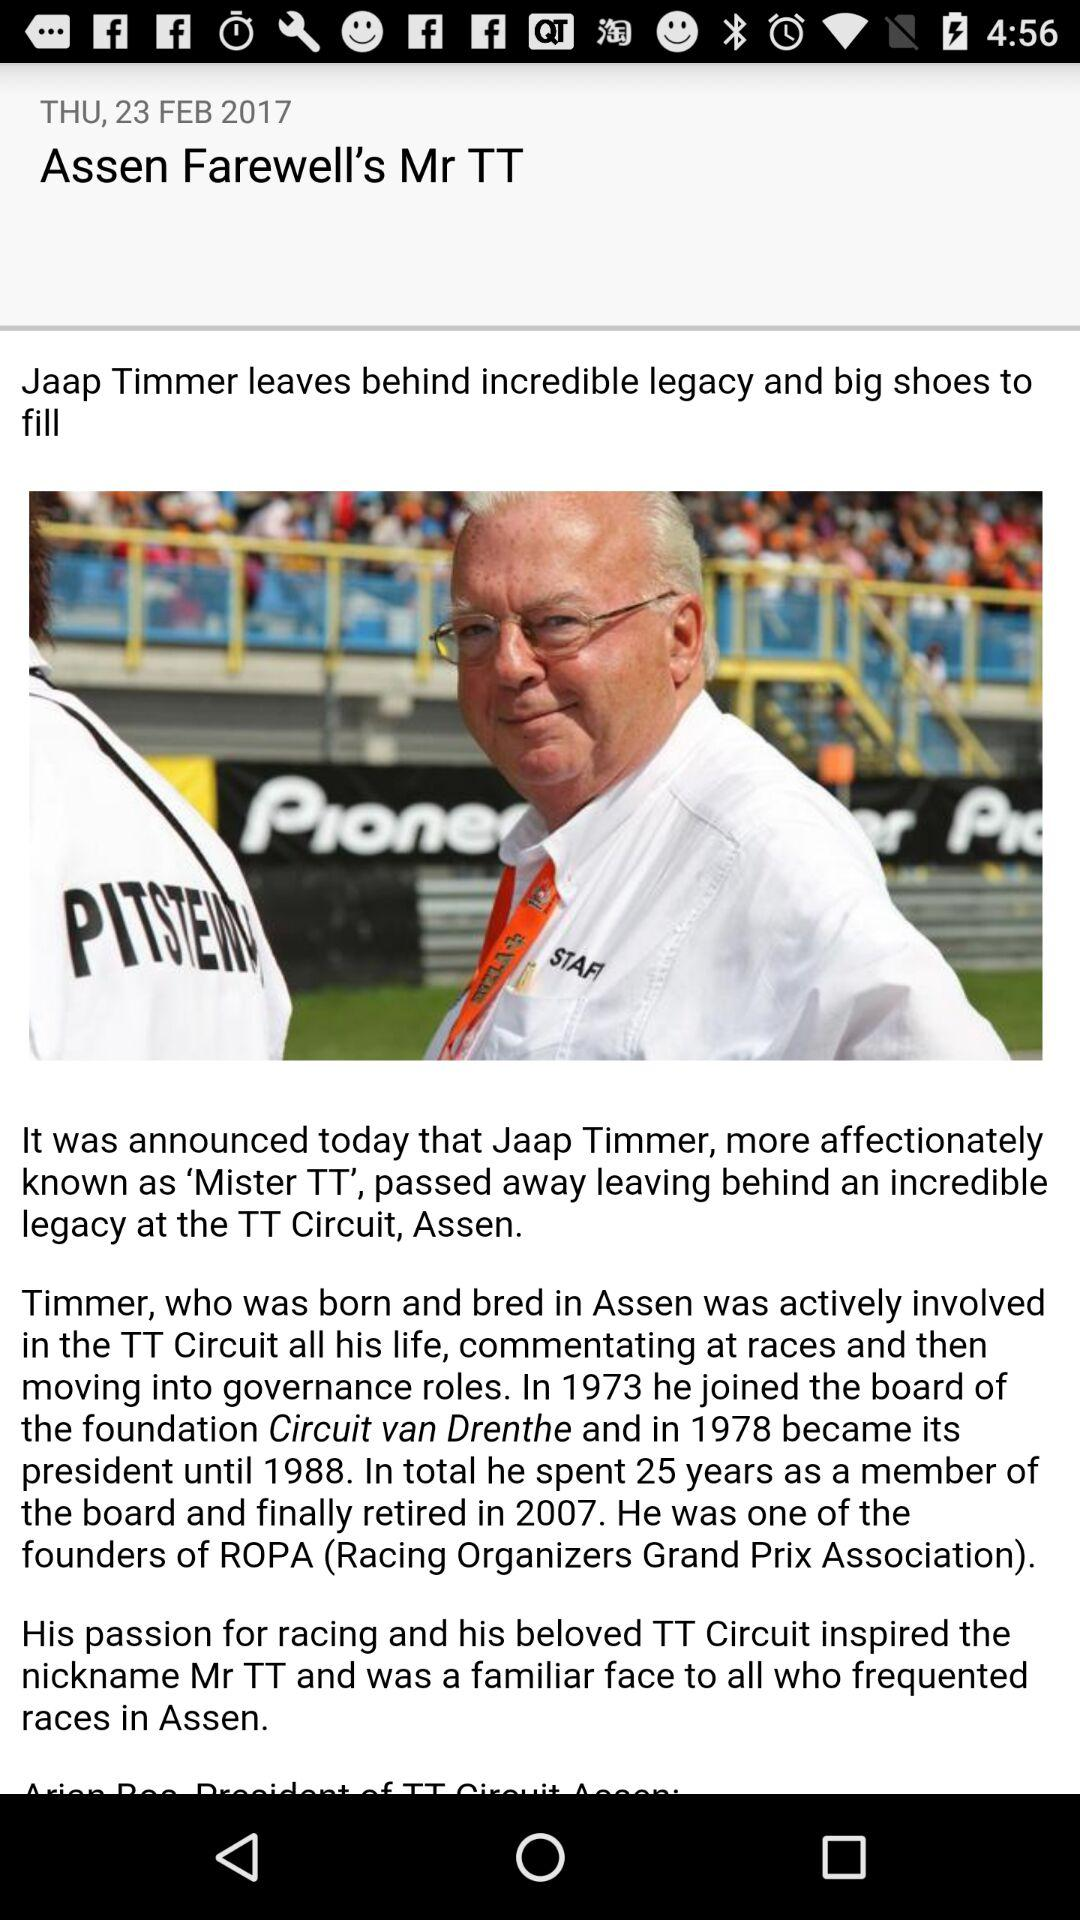When did he retire from the board? He retired from the board in 2007. 